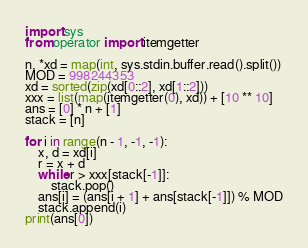<code> <loc_0><loc_0><loc_500><loc_500><_Python_>import sys
from operator import itemgetter

n, *xd = map(int, sys.stdin.buffer.read().split())
MOD = 998244353
xd = sorted(zip(xd[0::2], xd[1::2]))
xxx = list(map(itemgetter(0), xd)) + [10 ** 10]
ans = [0] * n + [1]
stack = [n]

for i in range(n - 1, -1, -1):
    x, d = xd[i]
    r = x + d
    while r > xxx[stack[-1]]:
        stack.pop()
    ans[i] = (ans[i + 1] + ans[stack[-1]]) % MOD
    stack.append(i)
print(ans[0])
</code> 